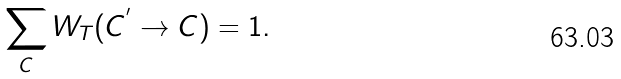<formula> <loc_0><loc_0><loc_500><loc_500>\sum _ { C } W _ { T } ( C ^ { ^ { \prime } } \rightarrow C ) = 1 .</formula> 